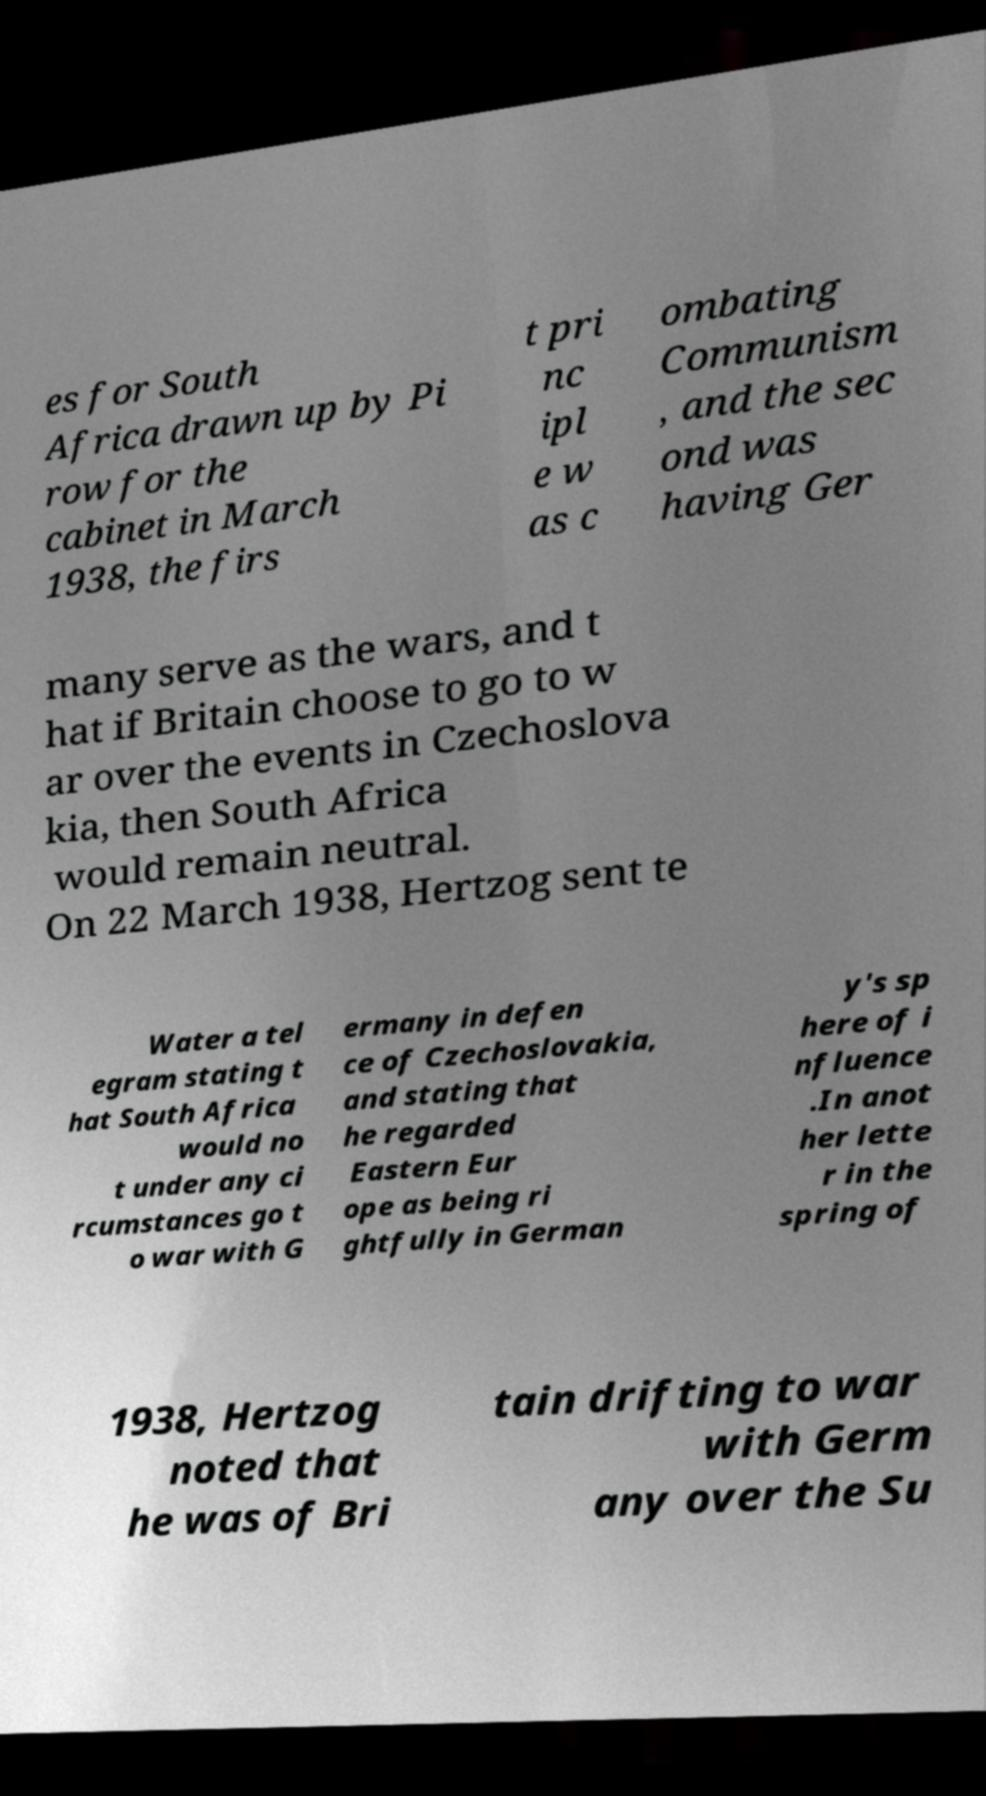I need the written content from this picture converted into text. Can you do that? es for South Africa drawn up by Pi row for the cabinet in March 1938, the firs t pri nc ipl e w as c ombating Communism , and the sec ond was having Ger many serve as the wars, and t hat if Britain choose to go to w ar over the events in Czechoslova kia, then South Africa would remain neutral. On 22 March 1938, Hertzog sent te Water a tel egram stating t hat South Africa would no t under any ci rcumstances go t o war with G ermany in defen ce of Czechoslovakia, and stating that he regarded Eastern Eur ope as being ri ghtfully in German y's sp here of i nfluence .In anot her lette r in the spring of 1938, Hertzog noted that he was of Bri tain drifting to war with Germ any over the Su 